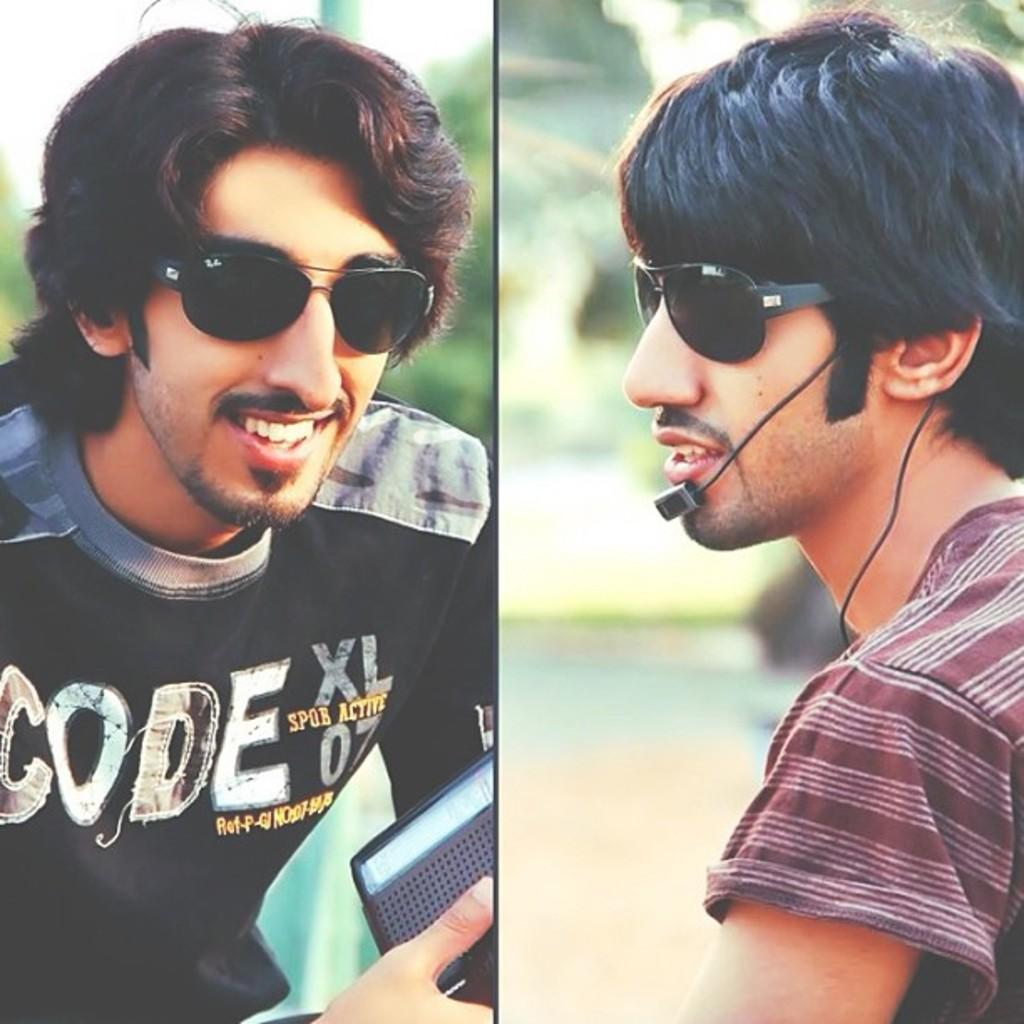Please provide a concise description of this image. In this image, on the right side, we can see a man wearing black color goggles and keeping microphone. On the left side, we can see a man wearing a black color shirt and holding an object in his hand. 